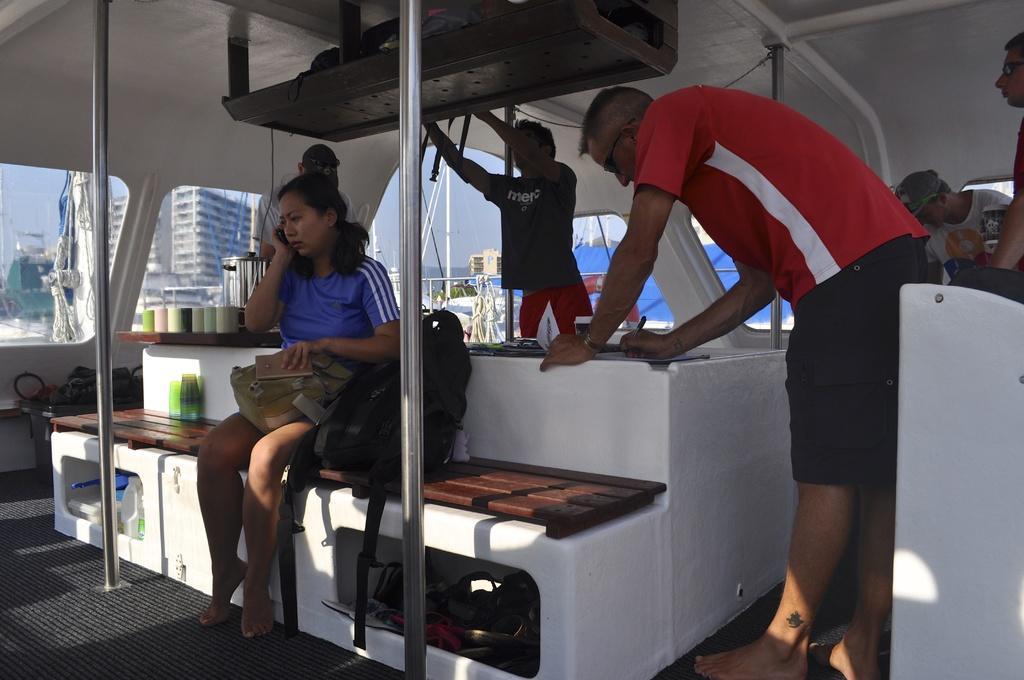Describe this image in one or two sentences. In this picture there is a woman sitting and holding the book and device and there is a man standing and writing and there are objects on the bench. At the back there are group of people standing and there are bottles on the table. At the top there are objects in the shelf. At the back there are buildings and trees and their might be boats. At the top there is sky. At the bottom there is water and there is a floor. 